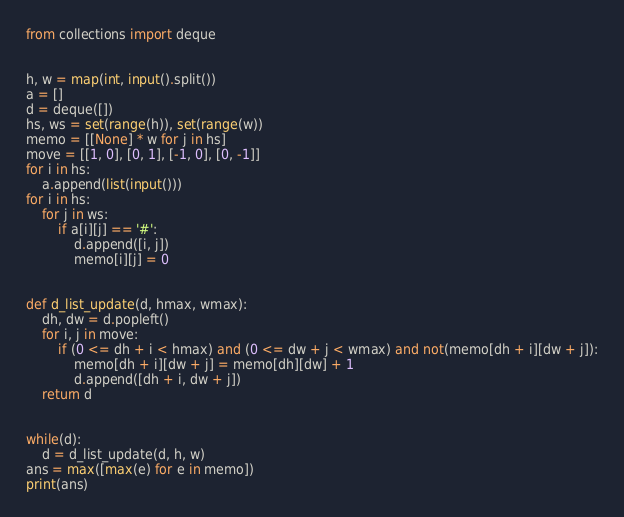Convert code to text. <code><loc_0><loc_0><loc_500><loc_500><_Python_>from collections import deque


h, w = map(int, input().split())
a = []
d = deque([])
hs, ws = set(range(h)), set(range(w))
memo = [[None] * w for j in hs]
move = [[1, 0], [0, 1], [-1, 0], [0, -1]]
for i in hs:
    a.append(list(input()))
for i in hs:
    for j in ws:
        if a[i][j] == '#':
            d.append([i, j])
            memo[i][j] = 0


def d_list_update(d, hmax, wmax):
    dh, dw = d.popleft()
    for i, j in move:
        if (0 <= dh + i < hmax) and (0 <= dw + j < wmax) and not(memo[dh + i][dw + j]):
            memo[dh + i][dw + j] = memo[dh][dw] + 1
            d.append([dh + i, dw + j])
    return d


while(d):
    d = d_list_update(d, h, w)
ans = max([max(e) for e in memo])
print(ans)</code> 